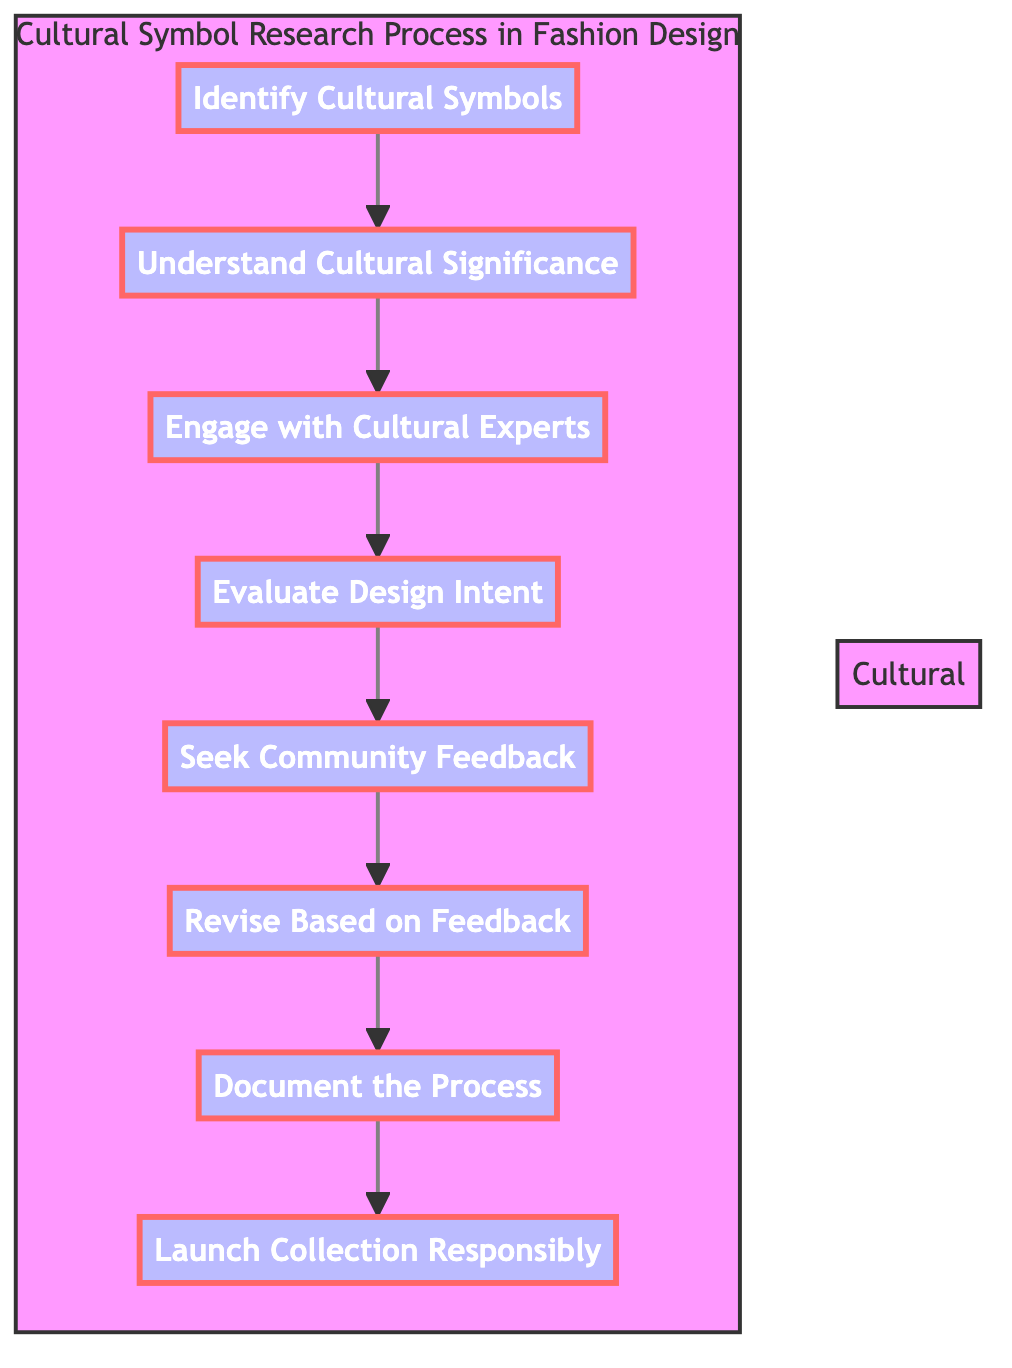What is the first step in the diagram? The diagram shows that the first step in the process is "Identify Cultural Symbols," as indicated at the starting point of the flowchart
Answer: Identify Cultural Symbols How many steps are there in total? The diagram includes a total of eight steps, which can be counted from top to bottom along the flow chart
Answer: 8 What step comes after "Engage with Cultural Experts"? Based on the directional arrows in the diagram, the step that comes after "Engage with Cultural Experts" is "Evaluate Design Intent"
Answer: Evaluate Design Intent What is the last step in the process? The diagram clearly shows that the last step in the process is "Launch Collection Responsibly," as it is positioned at the end of the flow chart
Answer: Launch Collection Responsibly Which step involves consulting with community leaders? The step that involves consulting with community leaders is "Engage with Cultural Experts," as it specifically mentions consulting with anthropologists, historians, or community leaders
Answer: Engage with Cultural Experts How does the feedback cycle work in the diagram? The process of feedback involves two steps: "Seek Community Feedback" is followed by "Revise Based on Feedback," indicating that community input is considered before finalizing designs
Answer: Seek Community Feedback, Revise Based on Feedback What key action is emphasized before launching a collection? The diagram highlights the importance of "Document the Process" as a crucial step before launching the fashion collection, ensuring that all research and feedback is recorded
Answer: Document the Process Is there a unique feature in the flow chart related to cultural consultation? Yes, the unique feature is the step "Engage with Cultural Experts," indicating the intentional act of consulting knowledgeable individuals to enhance the design process
Answer: Engage with Cultural Experts 